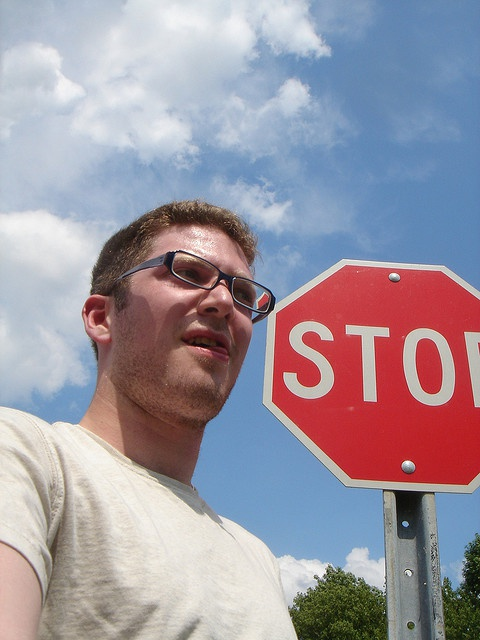Describe the objects in this image and their specific colors. I can see people in darkgray, lightgray, maroon, and brown tones and stop sign in darkgray and brown tones in this image. 